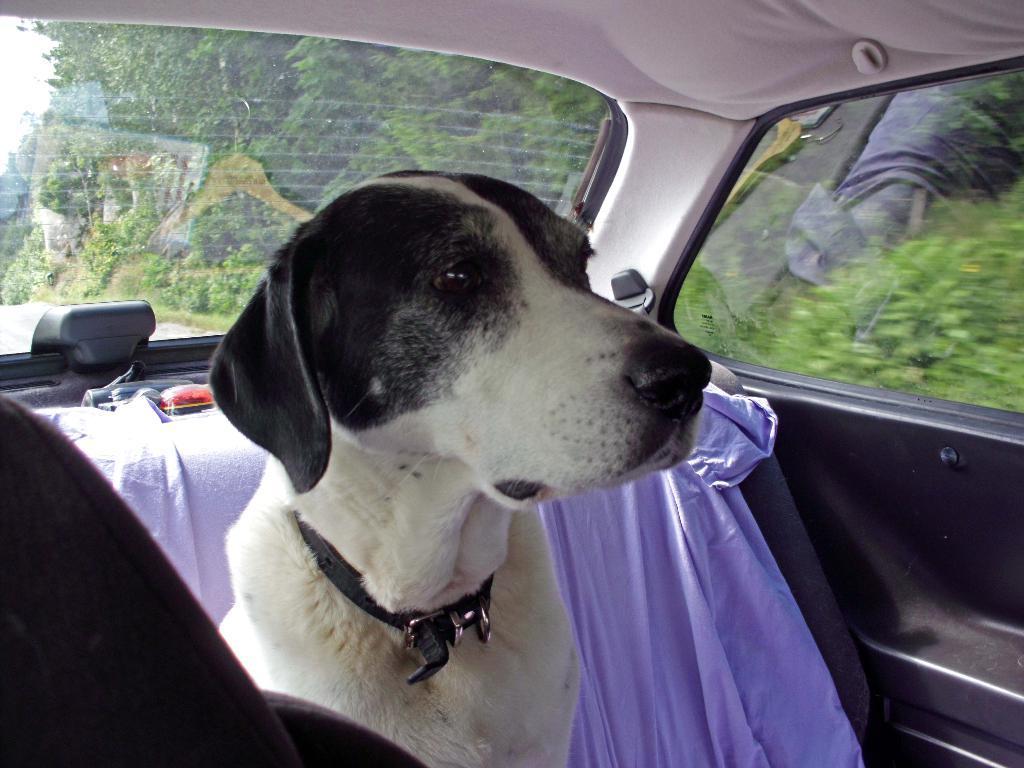Please provide a concise description of this image. In this picture we can see a dog sitting inside a car. Through car glasses we can see trees. 